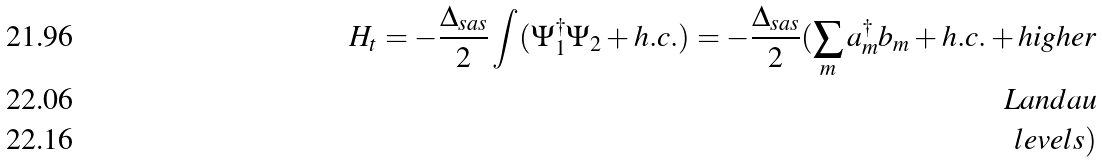Convert formula to latex. <formula><loc_0><loc_0><loc_500><loc_500>H _ { t } = - \frac { \Delta _ { s a s } } { 2 } \int ( \Psi _ { 1 } ^ { \dagger } \Psi _ { 2 } + h . c . ) = - \frac { \Delta _ { s a s } } { 2 } ( \sum _ { m } a _ { m } ^ { \dagger } b _ { m } + h . c . + h i g h e r \\ \ L a n d a u \\ \ l e v e l s )</formula> 